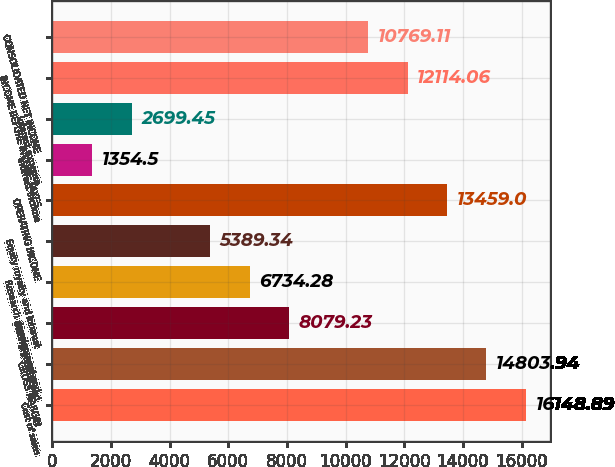<chart> <loc_0><loc_0><loc_500><loc_500><bar_chart><fcel>Cost of sales<fcel>GROSS MARGIN<fcel>Selling general and<fcel>Research development and<fcel>Equity royalty and interest<fcel>OPERATING INCOME<fcel>Interest income<fcel>Interest expense<fcel>INCOME BEFORE INCOME TAXES<fcel>CONSOLIDATED NET INCOME<nl><fcel>16148.9<fcel>14803.9<fcel>8079.23<fcel>6734.28<fcel>5389.34<fcel>13459<fcel>1354.5<fcel>2699.45<fcel>12114.1<fcel>10769.1<nl></chart> 